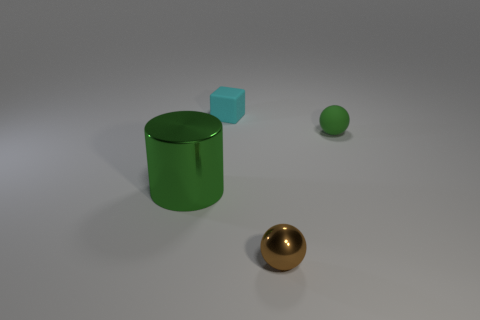Add 2 small cyan rubber blocks. How many objects exist? 6 Subtract all blocks. How many objects are left? 3 Subtract 1 green cylinders. How many objects are left? 3 Subtract all big gray shiny blocks. Subtract all big green metallic cylinders. How many objects are left? 3 Add 2 tiny cyan matte cubes. How many tiny cyan matte cubes are left? 3 Add 4 brown shiny things. How many brown shiny things exist? 5 